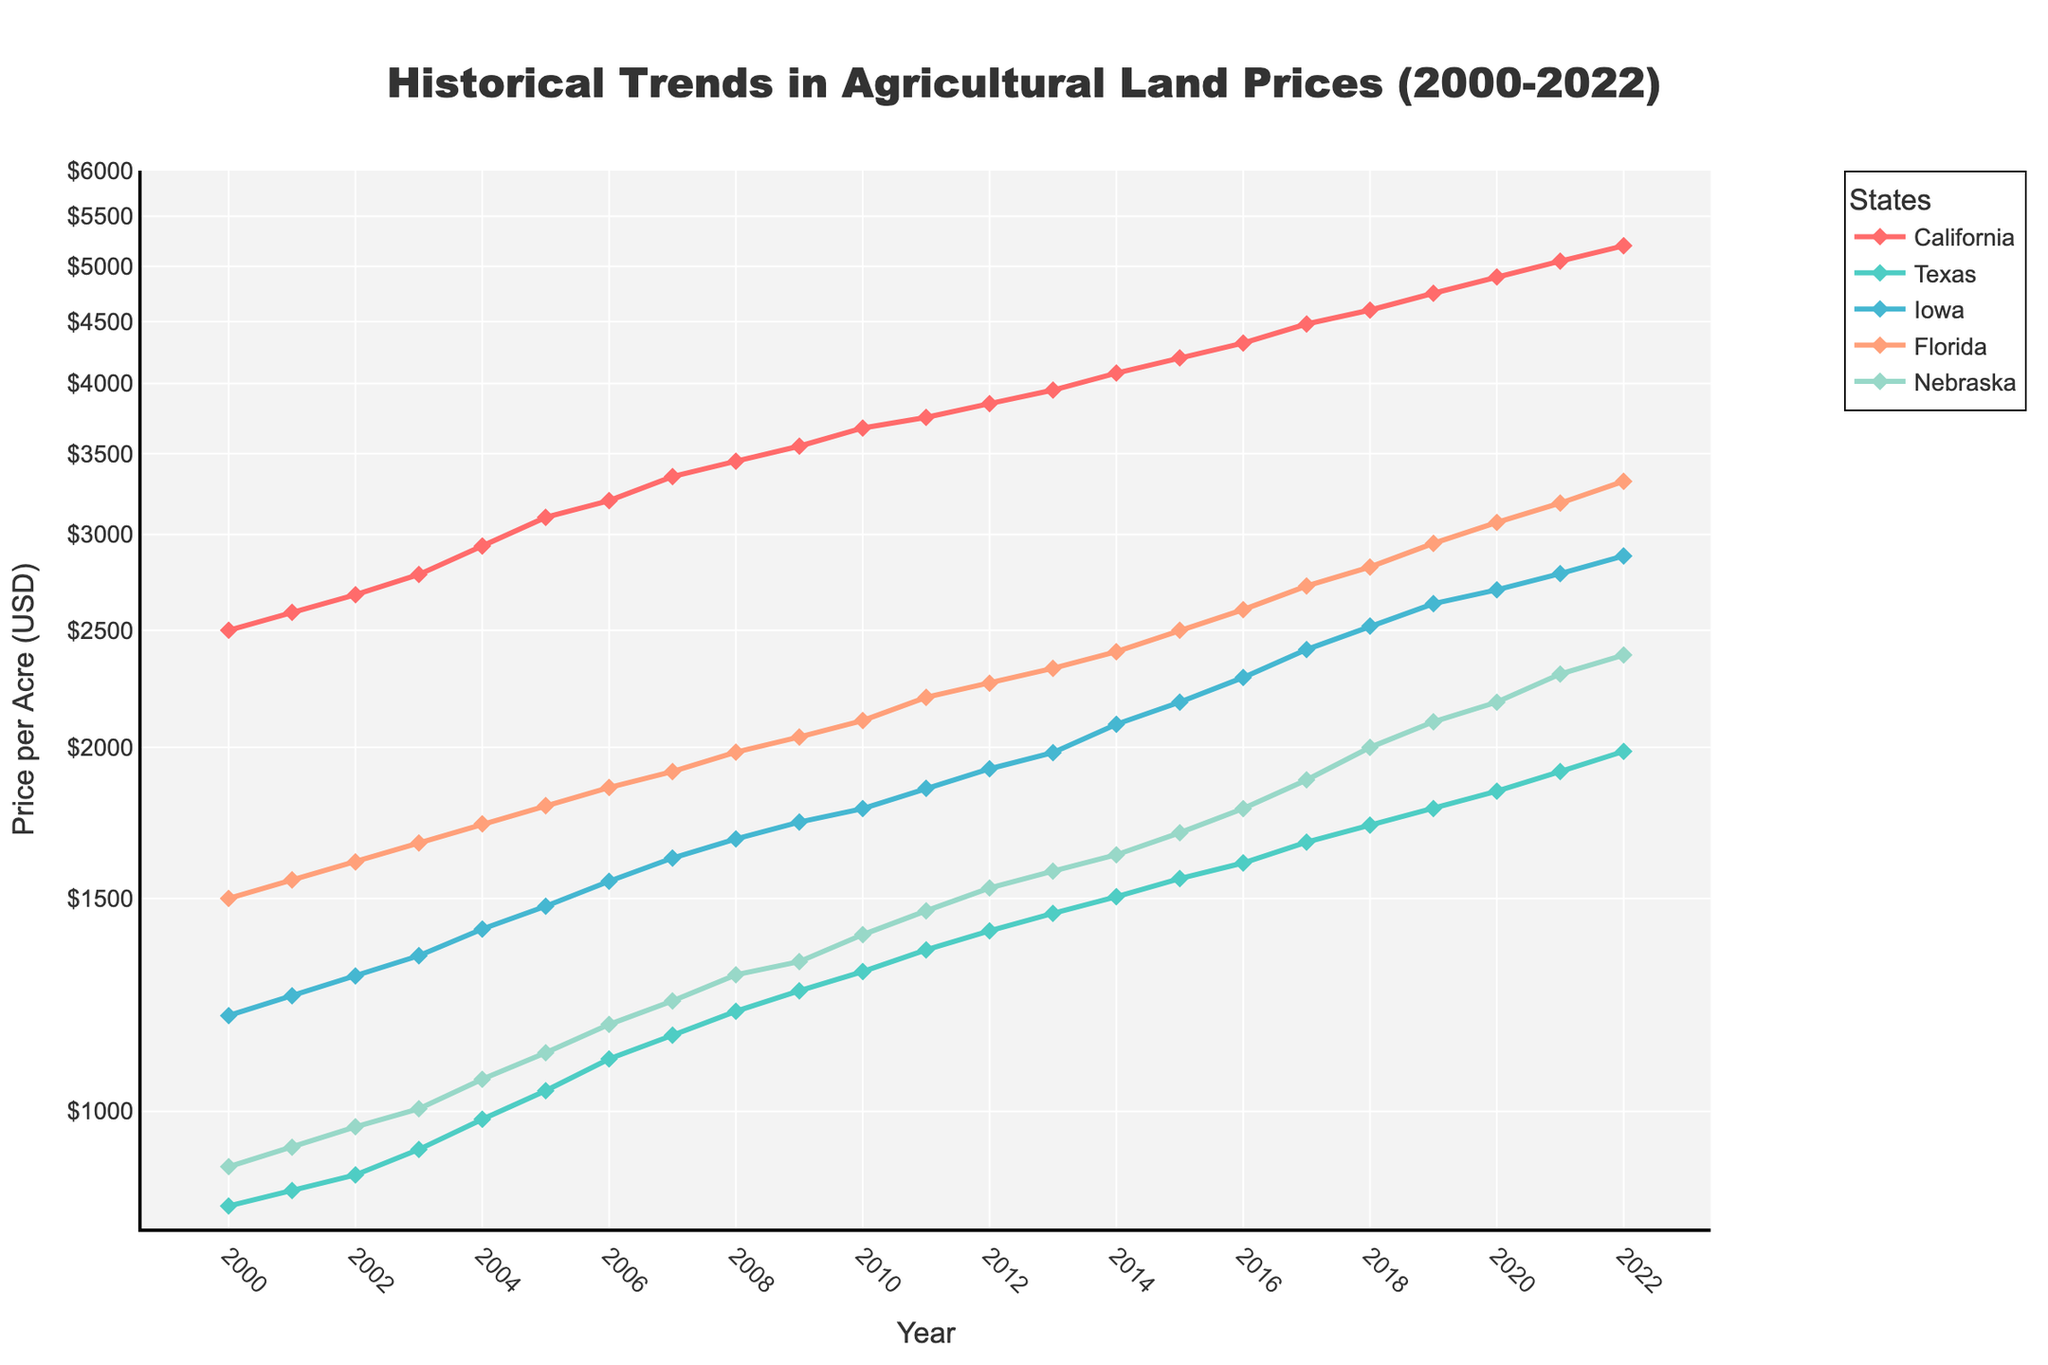what is the title of the figure? The title is displayed at the top of the figure. It is "Historical Trends in Agricultural Land Prices (2000-2022)".
Answer: Historical Trends in Agricultural Land Prices (2000-2022) Which state had the highest agricultural land price in 2022? To determine this, look at the end points of each line plot for the year 2022. The California line is at the highest position.
Answer: California what is the general trend in land prices for iowa from 2000 to 2022? Observe the line corresponding to Iowa from 2000 to 2022; the trend shows a steady increase in land prices over the entire period.
Answer: Steadily increasing which state had the least increase in land prices from 2000 to 2022? By examining the total vertical rise of each line from 2000 to 2022, the line for Texas shows the smallest increase.
Answer: Texas how many years does the data cover? The figure starts at 2000 and ends at 2022, indicating 23 years of data.
Answer: 23 years what was the price of agricultural land in florida in 2010? Locate the point on the Florida line at the year 2010; it is at the $2105 mark.
Answer: $2105 Between which years did Nebraska experience the highest rate of price increase? Look for the steepest slope on the line for Nebraska, which is between 2010 and 2011.
Answer: 2010 to 2011 how does california compare to the other states in terms of land prices? The California line is always higher than the other lines, indicating that California consistently has the highest land prices.
Answer: Higher than other states what is the price difference between Nebraska and Iowa in 2022? Locate the endpoints for Nebraska and Iowa in 2022 and subtract the Iowa value ($2880) from the Nebraska value ($2385).
Answer: $495 Which state had the highest relative increase in agricultural land prices from 2000 to 2022? Calculate the relative increase (final value divided by initial value) for each state and compare. California shows the highest relative increase given its high exponential rise over the log-scale.
Answer: California 